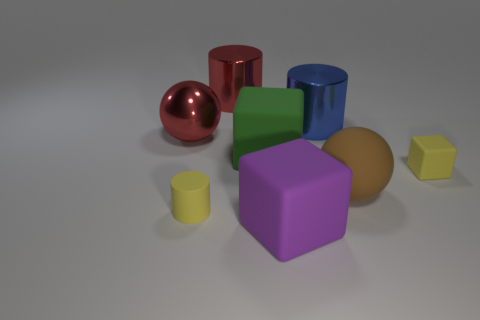What material is the object that is the same color as the large metal ball?
Offer a terse response. Metal. Is the color of the small cube the same as the rubber cylinder?
Make the answer very short. Yes. Do the tiny matte object that is in front of the brown matte thing and the small block have the same color?
Ensure brevity in your answer.  Yes. How many things are either large red metal balls or cylinders behind the yellow matte cylinder?
Provide a succinct answer. 3. The tiny thing that is the same color as the tiny cube is what shape?
Provide a short and direct response. Cylinder. What color is the small thing that is on the right side of the big blue object?
Offer a very short reply. Yellow. What number of things are red balls left of the big green rubber cube or tiny matte cylinders?
Provide a short and direct response. 2. There is a metal ball that is the same size as the green thing; what is its color?
Provide a succinct answer. Red. Are there more yellow matte things in front of the tiny yellow block than tiny blue things?
Provide a short and direct response. Yes. The large object that is both on the left side of the large green cube and in front of the large blue shiny cylinder is made of what material?
Give a very brief answer. Metal. 